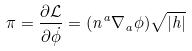Convert formula to latex. <formula><loc_0><loc_0><loc_500><loc_500>\pi = \frac { \partial \mathcal { L } } { \partial \dot { \phi } } = ( n ^ { a } \nabla _ { a } \phi ) \sqrt { | h | }</formula> 